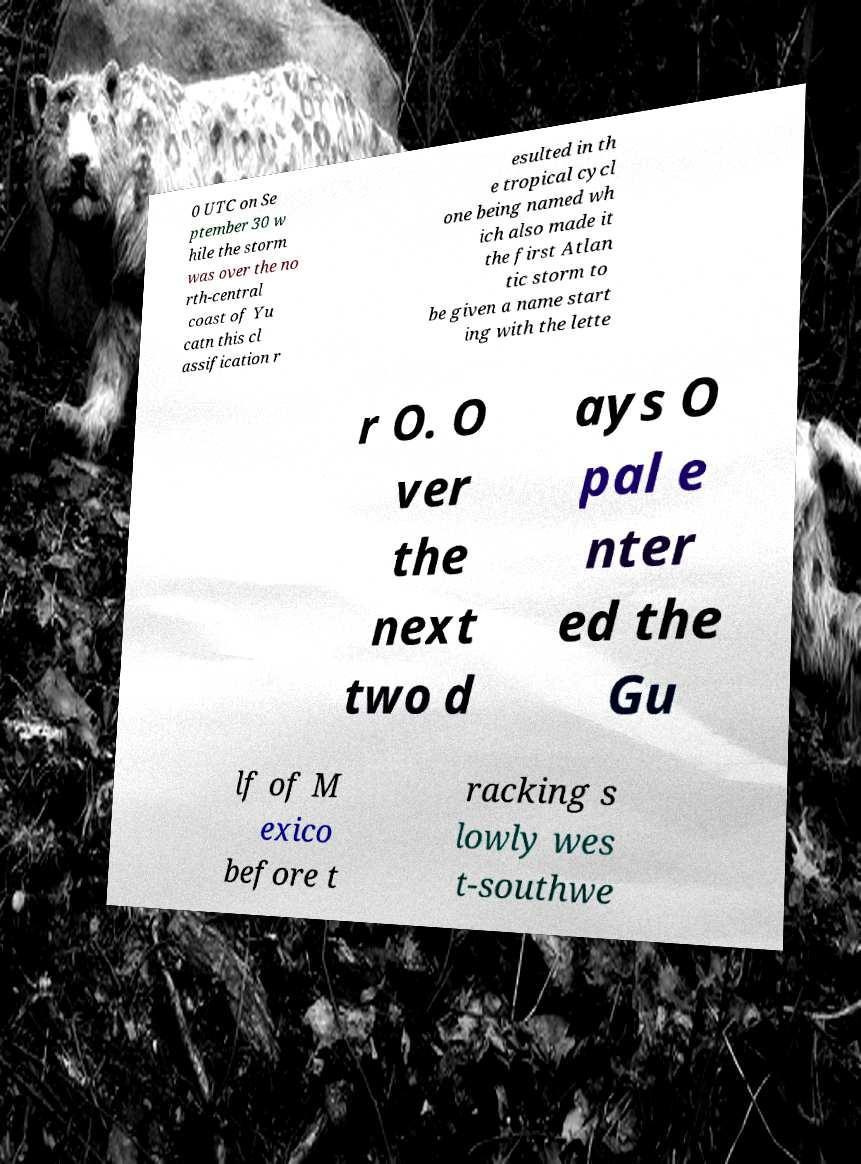What messages or text are displayed in this image? I need them in a readable, typed format. 0 UTC on Se ptember 30 w hile the storm was over the no rth-central coast of Yu catn this cl assification r esulted in th e tropical cycl one being named wh ich also made it the first Atlan tic storm to be given a name start ing with the lette r O. O ver the next two d ays O pal e nter ed the Gu lf of M exico before t racking s lowly wes t-southwe 